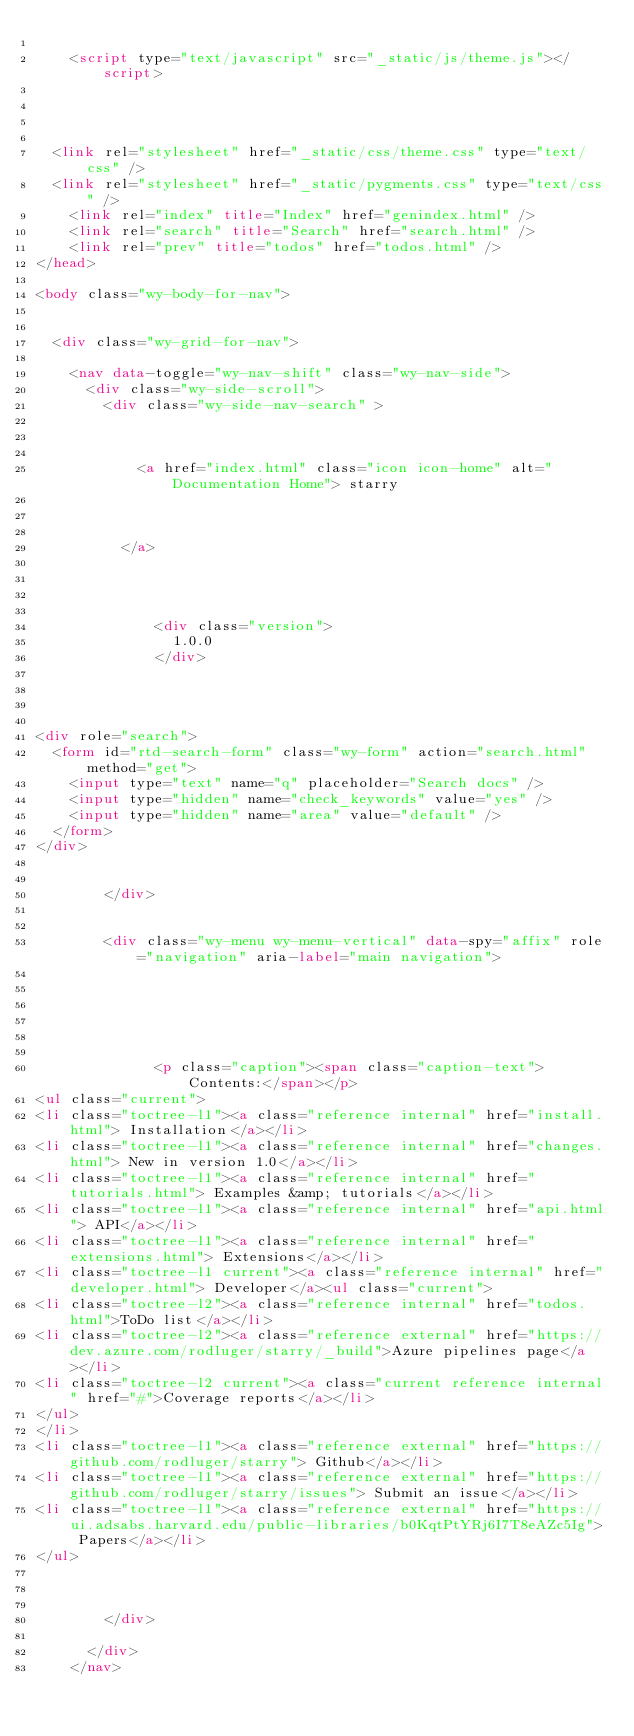Convert code to text. <code><loc_0><loc_0><loc_500><loc_500><_HTML_>    
    <script type="text/javascript" src="_static/js/theme.js"></script>

    

  
  <link rel="stylesheet" href="_static/css/theme.css" type="text/css" />
  <link rel="stylesheet" href="_static/pygments.css" type="text/css" />
    <link rel="index" title="Index" href="genindex.html" />
    <link rel="search" title="Search" href="search.html" />
    <link rel="prev" title="todos" href="todos.html" /> 
</head>

<body class="wy-body-for-nav">

   
  <div class="wy-grid-for-nav">
    
    <nav data-toggle="wy-nav-shift" class="wy-nav-side">
      <div class="wy-side-scroll">
        <div class="wy-side-nav-search" >
          

          
            <a href="index.html" class="icon icon-home" alt="Documentation Home"> starry
          

          
          </a>

          
            
            
              <div class="version">
                1.0.0
              </div>
            
          

          
<div role="search">
  <form id="rtd-search-form" class="wy-form" action="search.html" method="get">
    <input type="text" name="q" placeholder="Search docs" />
    <input type="hidden" name="check_keywords" value="yes" />
    <input type="hidden" name="area" value="default" />
  </form>
</div>

          
        </div>

        
        <div class="wy-menu wy-menu-vertical" data-spy="affix" role="navigation" aria-label="main navigation">
          
            
            
              
            
            
              <p class="caption"><span class="caption-text">Contents:</span></p>
<ul class="current">
<li class="toctree-l1"><a class="reference internal" href="install.html"> Installation</a></li>
<li class="toctree-l1"><a class="reference internal" href="changes.html"> New in version 1.0</a></li>
<li class="toctree-l1"><a class="reference internal" href="tutorials.html"> Examples &amp; tutorials</a></li>
<li class="toctree-l1"><a class="reference internal" href="api.html"> API</a></li>
<li class="toctree-l1"><a class="reference internal" href="extensions.html"> Extensions</a></li>
<li class="toctree-l1 current"><a class="reference internal" href="developer.html"> Developer</a><ul class="current">
<li class="toctree-l2"><a class="reference internal" href="todos.html">ToDo list</a></li>
<li class="toctree-l2"><a class="reference external" href="https://dev.azure.com/rodluger/starry/_build">Azure pipelines page</a></li>
<li class="toctree-l2 current"><a class="current reference internal" href="#">Coverage reports</a></li>
</ul>
</li>
<li class="toctree-l1"><a class="reference external" href="https://github.com/rodluger/starry"> Github</a></li>
<li class="toctree-l1"><a class="reference external" href="https://github.com/rodluger/starry/issues"> Submit an issue</a></li>
<li class="toctree-l1"><a class="reference external" href="https://ui.adsabs.harvard.edu/public-libraries/b0KqtPtYRj6I7T8eAZc5Ig"> Papers</a></li>
</ul>

            
          
        </div>
        
      </div>
    </nav>
</code> 